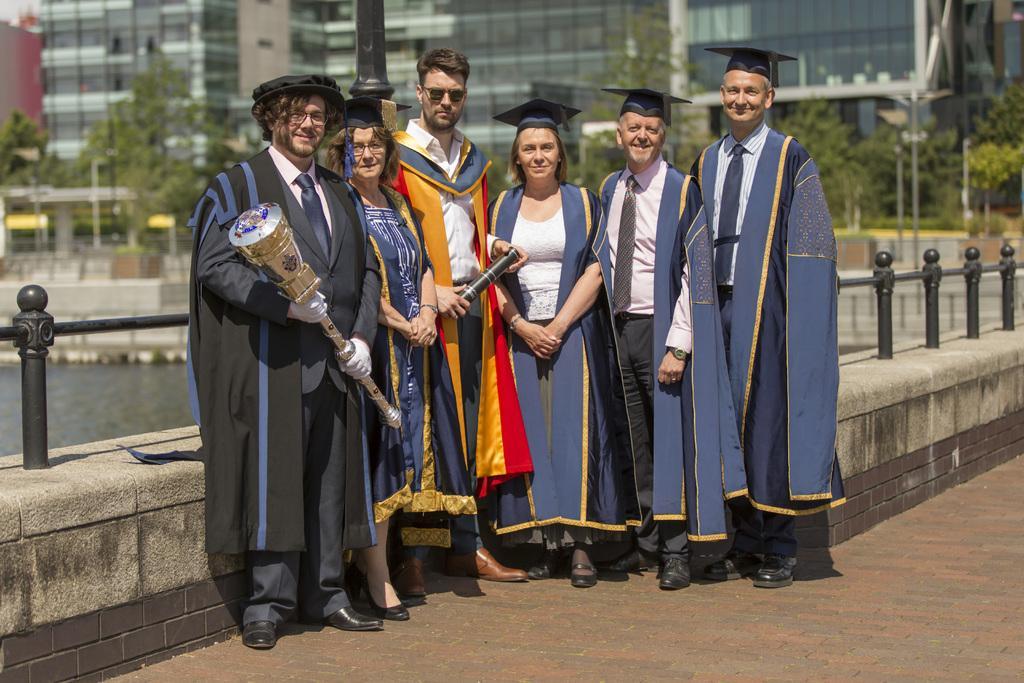Can you describe this image briefly? In this image we can see persons standing on the floor in costumes. In the background we can see iron fence, trees and buildings. 